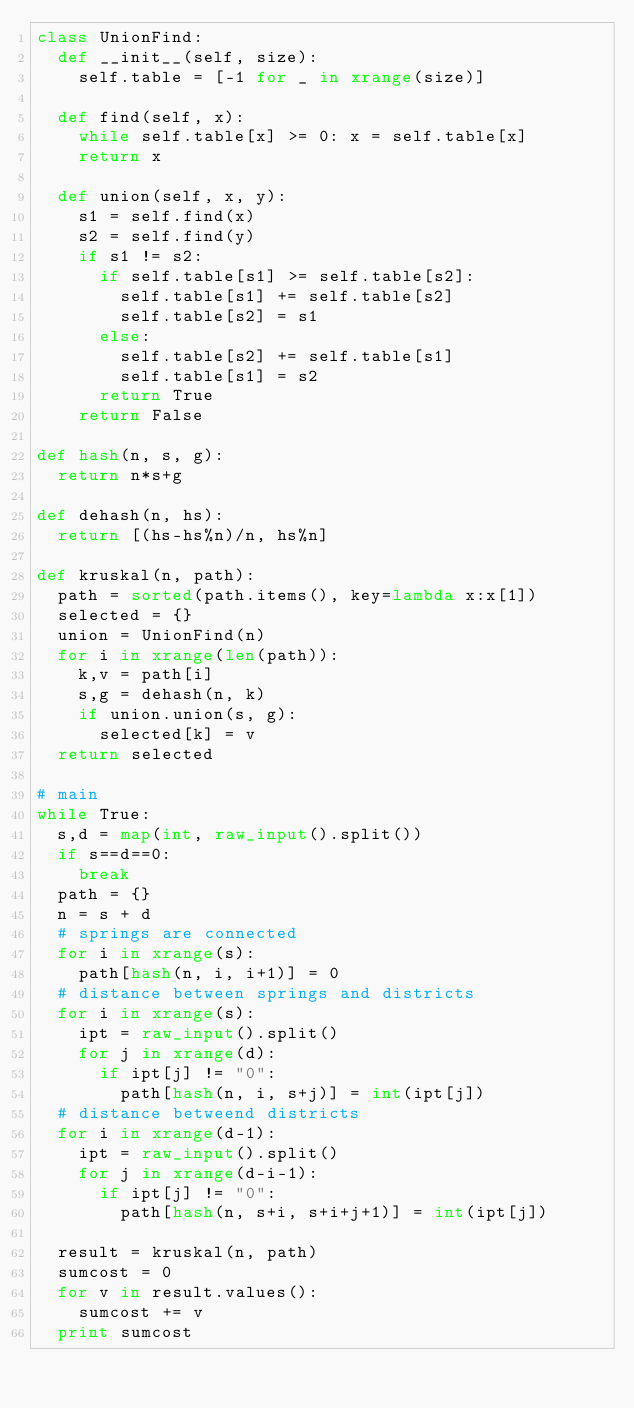<code> <loc_0><loc_0><loc_500><loc_500><_Python_>class UnionFind:
  def __init__(self, size):
    self.table = [-1 for _ in xrange(size)]

  def find(self, x):
    while self.table[x] >= 0: x = self.table[x]
    return x

  def union(self, x, y):
    s1 = self.find(x)
    s2 = self.find(y)
    if s1 != s2:
      if self.table[s1] >= self.table[s2]:
        self.table[s1] += self.table[s2]
        self.table[s2] = s1
      else:
        self.table[s2] += self.table[s1]
        self.table[s1] = s2
      return True
    return False

def hash(n, s, g):
  return n*s+g

def dehash(n, hs):
  return [(hs-hs%n)/n, hs%n]

def kruskal(n, path):
  path = sorted(path.items(), key=lambda x:x[1])
  selected = {}
  union = UnionFind(n)
  for i in xrange(len(path)):
    k,v = path[i]
    s,g = dehash(n, k)
    if union.union(s, g):
      selected[k] = v
  return selected

# main
while True:
  s,d = map(int, raw_input().split())
  if s==d==0:
    break
  path = {}
  n = s + d
  # springs are connected
  for i in xrange(s):
    path[hash(n, i, i+1)] = 0
  # distance between springs and districts
  for i in xrange(s):
    ipt = raw_input().split()
    for j in xrange(d):
      if ipt[j] != "0":
        path[hash(n, i, s+j)] = int(ipt[j])
  # distance betweend districts
  for i in xrange(d-1):
    ipt = raw_input().split()
    for j in xrange(d-i-1):
      if ipt[j] != "0":
        path[hash(n, s+i, s+i+j+1)] = int(ipt[j])

  result = kruskal(n, path)
  sumcost = 0
  for v in result.values():
    sumcost += v
  print sumcost</code> 